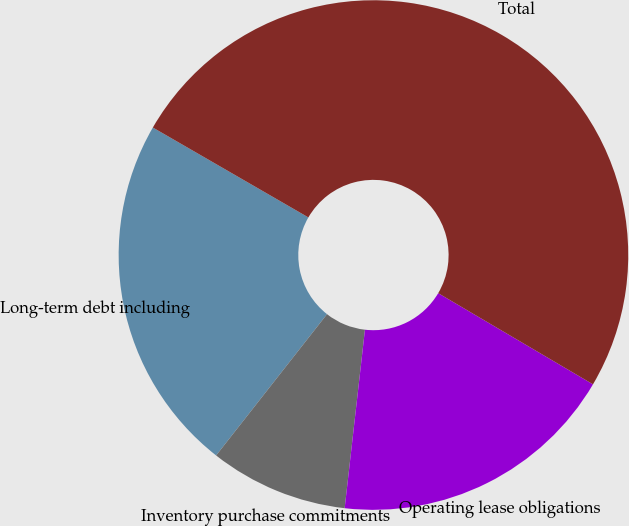<chart> <loc_0><loc_0><loc_500><loc_500><pie_chart><fcel>Long-term debt including<fcel>Inventory purchase commitments<fcel>Operating lease obligations<fcel>Total<nl><fcel>22.75%<fcel>8.79%<fcel>18.33%<fcel>50.13%<nl></chart> 